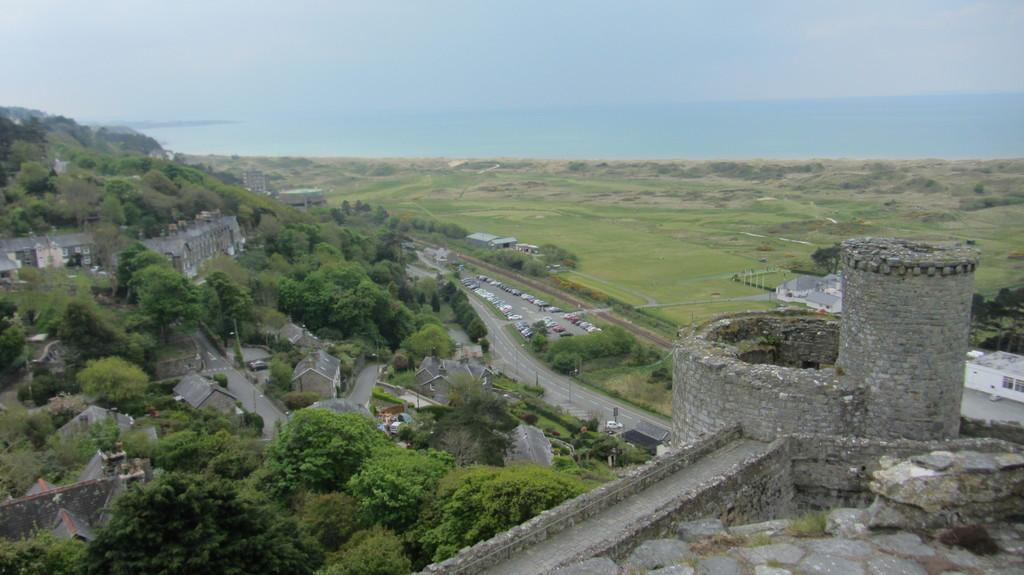Describe this image in one or two sentences. This image consists of a fort. To the left, there are roads along with trees and plants. At the top, there is a sky. 